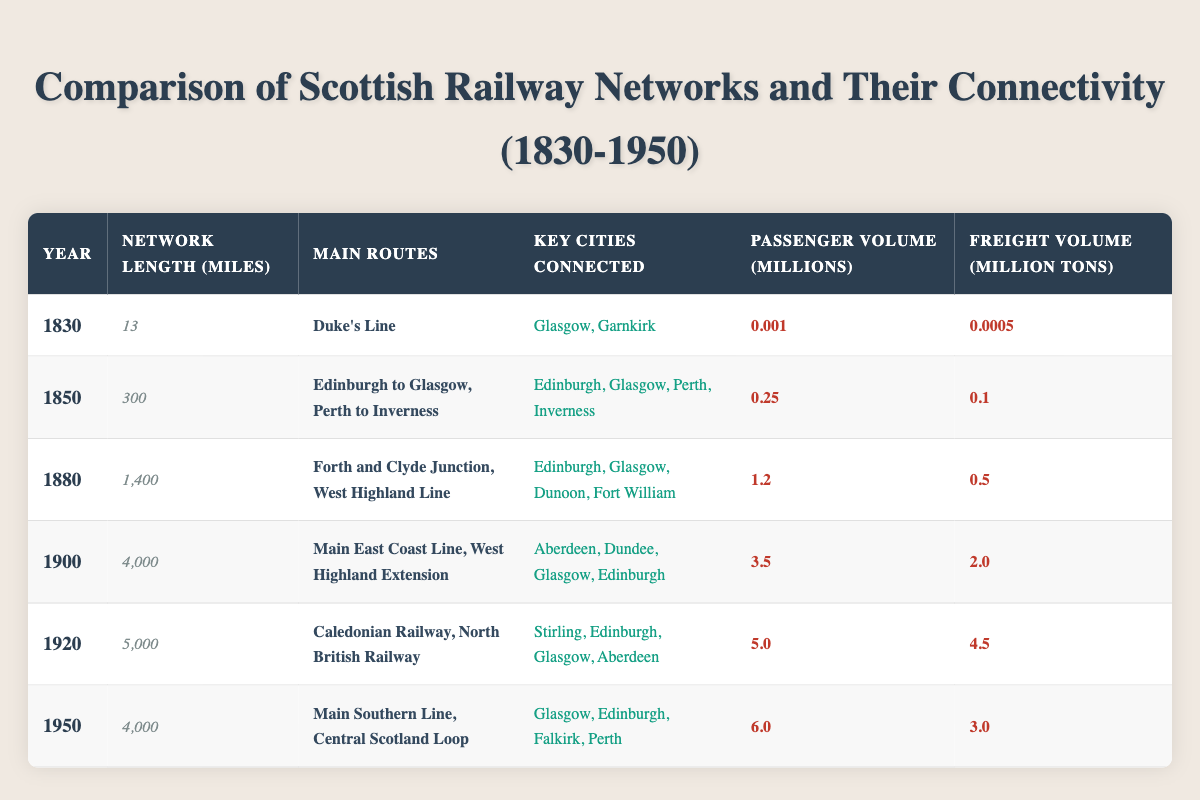What was the network length in miles in 1850? The table indicates that the network length in miles for the year 1850 is specifically mentioned under the column for network length. Reviewing that row confirms the value is 300 miles.
Answer: 300 Which main routes were specified in 1880? By looking at the column for main routes for the year 1880, we find that it lists "Forth and Clyde Junction" and "West Highland Line" as the main routes during that time.
Answer: Forth and Clyde Junction, West Highland Line What was the passenger volume in millions in 1920? The passenger volume for the year 1920 can be found in its respective row in the table under the column for passenger volume, which lists it as 5.0 million.
Answer: 5.0 Did the network length increase from 1830 to 1950? Comparing the network lengths listed in the years 1830 (13 miles) and 1950 (4000 miles), it is clear that there was a significant increase, confirming that the network length did indeed increase over this period.
Answer: Yes What was the total passenger volume from 1880 to 1950? The passenger volumes for the years 1880 (1.2 million), 1900 (3.5 million), 1920 (5.0 million), and 1950 (6.0 million) need to be added together. Their sum is 1.2 + 3.5 + 5.0 + 6.0 = 15.7 million.
Answer: 15.7 Which year had the highest freight volume, and what was the value? Looking through the freight volume column, the maximum value appears in 1920 with a figure of 4.5 million tons. Thus, 1920 is the year with the highest freight volume.
Answer: 1920, 4.5 Calculate the average network length from 1830 to 1950. The network lengths are 13, 300, 1400, 4000, 5000, and 4000 miles. To find the average, we sum these lengths: 13 + 300 + 1400 + 4000 + 5000 + 4000 = 13613, then divide by 6 (the number of data points), yielding an average length of 2268.83 miles.
Answer: 2268.83 What change in passenger volume occurred from 1900 to 1920? Subtracting the passenger volume in 1900 (3.5 million) from the volume in 1920 (5.0 million) shows an increase: 5.0 - 3.5 = 1.5 million. This indicates that there was an increase in passenger volume by 1.5 million from 1900 to 1920.
Answer: 1.5 million Which key cities were connected by rail in 1950? Referring to the respective row from the table for the year 1950, the column titled "Key Cities Connected" lists "Glasgow, Edinburgh, Falkirk, Perth" as the connected cities.
Answer: Glasgow, Edinburgh, Falkirk, Perth How many miles longer was the railway network in 1920 compared to 1900? The network lengths for 1920 (5000 miles) and 1900 (4000 miles) can be compared by subtracting the two values: 5000 - 4000 = 1000 miles, indicating that the network was 1000 miles longer in 1920 than in 1900.
Answer: 1000 miles 